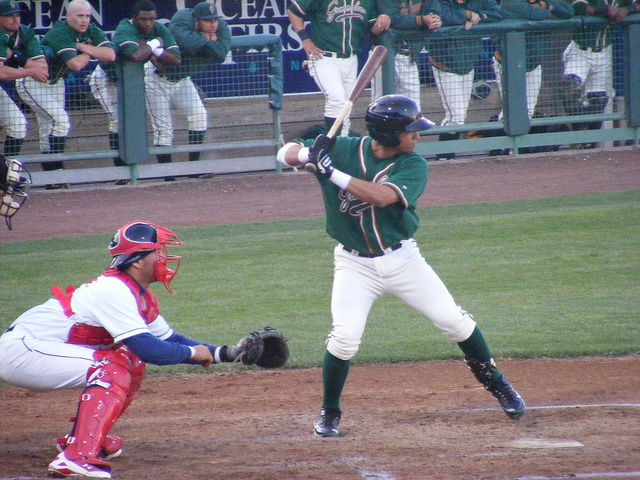Describe the objects in this image and their specific colors. I can see people in gray, lavender, and brown tones, people in gray, lavender, teal, and black tones, people in gray, blue, lavender, and darkgray tones, people in gray, darkgray, teal, and black tones, and people in gray, darkgray, and blue tones in this image. 